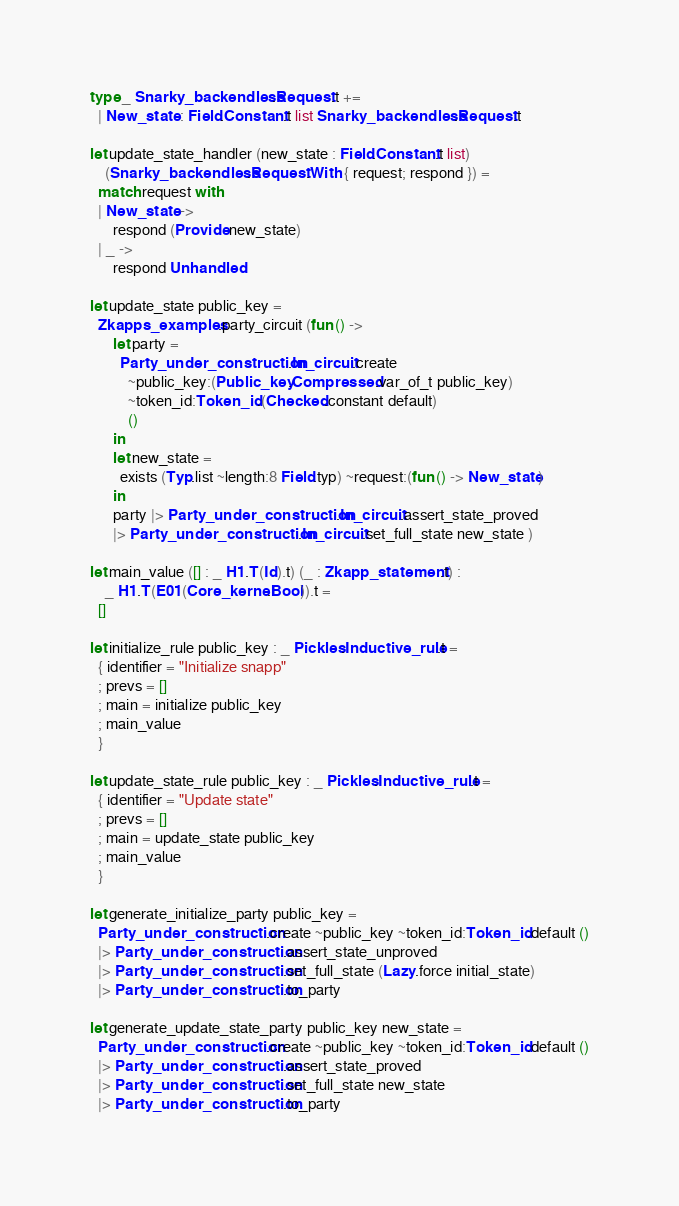Convert code to text. <code><loc_0><loc_0><loc_500><loc_500><_OCaml_>
type _ Snarky_backendless.Request.t +=
  | New_state : Field.Constant.t list Snarky_backendless.Request.t

let update_state_handler (new_state : Field.Constant.t list)
    (Snarky_backendless.Request.With { request; respond }) =
  match request with
  | New_state ->
      respond (Provide new_state)
  | _ ->
      respond Unhandled

let update_state public_key =
  Zkapps_examples.party_circuit (fun () ->
      let party =
        Party_under_construction.In_circuit.create
          ~public_key:(Public_key.Compressed.var_of_t public_key)
          ~token_id:Token_id.(Checked.constant default)
          ()
      in
      let new_state =
        exists (Typ.list ~length:8 Field.typ) ~request:(fun () -> New_state)
      in
      party |> Party_under_construction.In_circuit.assert_state_proved
      |> Party_under_construction.In_circuit.set_full_state new_state )

let main_value ([] : _ H1.T(Id).t) (_ : Zkapp_statement.t) :
    _ H1.T(E01(Core_kernel.Bool)).t =
  []

let initialize_rule public_key : _ Pickles.Inductive_rule.t =
  { identifier = "Initialize snapp"
  ; prevs = []
  ; main = initialize public_key
  ; main_value
  }

let update_state_rule public_key : _ Pickles.Inductive_rule.t =
  { identifier = "Update state"
  ; prevs = []
  ; main = update_state public_key
  ; main_value
  }

let generate_initialize_party public_key =
  Party_under_construction.create ~public_key ~token_id:Token_id.default ()
  |> Party_under_construction.assert_state_unproved
  |> Party_under_construction.set_full_state (Lazy.force initial_state)
  |> Party_under_construction.to_party

let generate_update_state_party public_key new_state =
  Party_under_construction.create ~public_key ~token_id:Token_id.default ()
  |> Party_under_construction.assert_state_proved
  |> Party_under_construction.set_full_state new_state
  |> Party_under_construction.to_party
</code> 